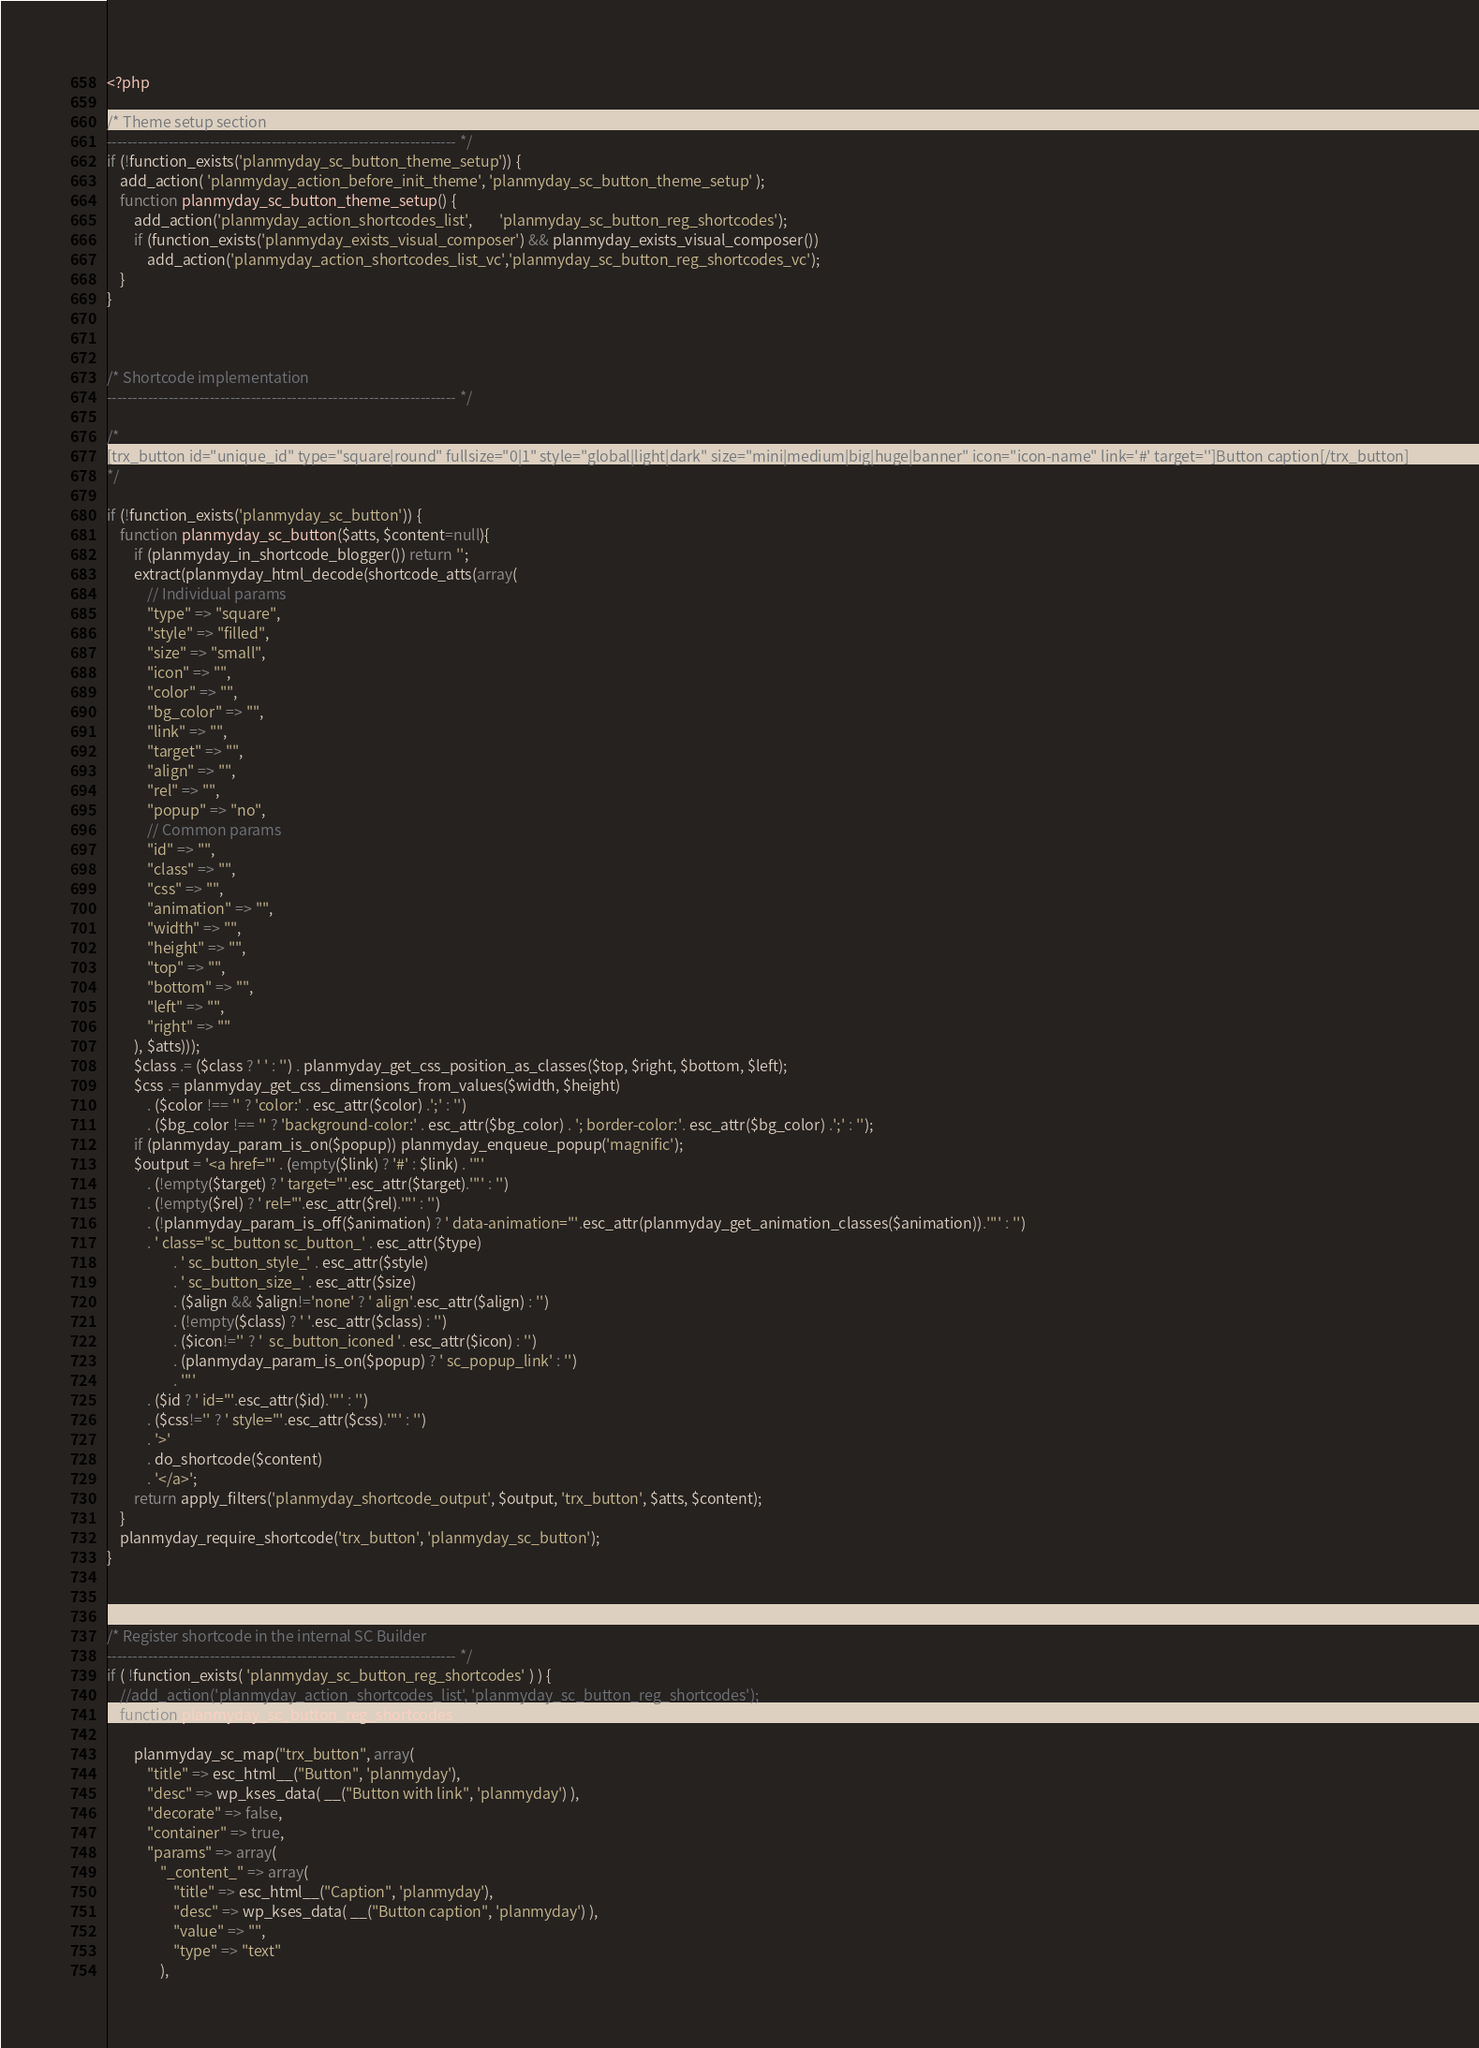<code> <loc_0><loc_0><loc_500><loc_500><_PHP_><?php

/* Theme setup section
-------------------------------------------------------------------- */
if (!function_exists('planmyday_sc_button_theme_setup')) {
	add_action( 'planmyday_action_before_init_theme', 'planmyday_sc_button_theme_setup' );
	function planmyday_sc_button_theme_setup() {
		add_action('planmyday_action_shortcodes_list', 		'planmyday_sc_button_reg_shortcodes');
		if (function_exists('planmyday_exists_visual_composer') && planmyday_exists_visual_composer())
			add_action('planmyday_action_shortcodes_list_vc','planmyday_sc_button_reg_shortcodes_vc');
	}
}



/* Shortcode implementation
-------------------------------------------------------------------- */

/*
[trx_button id="unique_id" type="square|round" fullsize="0|1" style="global|light|dark" size="mini|medium|big|huge|banner" icon="icon-name" link='#' target='']Button caption[/trx_button]
*/

if (!function_exists('planmyday_sc_button')) {	
	function planmyday_sc_button($atts, $content=null){	
		if (planmyday_in_shortcode_blogger()) return '';
		extract(planmyday_html_decode(shortcode_atts(array(
			// Individual params
			"type" => "square",
			"style" => "filled",
			"size" => "small",
			"icon" => "",
			"color" => "",
			"bg_color" => "",
			"link" => "",
			"target" => "",
			"align" => "",
			"rel" => "",
			"popup" => "no",
			// Common params
			"id" => "",
			"class" => "",
			"css" => "",
			"animation" => "",
			"width" => "",
			"height" => "",
			"top" => "",
			"bottom" => "",
			"left" => "",
			"right" => ""
		), $atts)));
		$class .= ($class ? ' ' : '') . planmyday_get_css_position_as_classes($top, $right, $bottom, $left);
		$css .= planmyday_get_css_dimensions_from_values($width, $height)
			. ($color !== '' ? 'color:' . esc_attr($color) .';' : '')
			. ($bg_color !== '' ? 'background-color:' . esc_attr($bg_color) . '; border-color:'. esc_attr($bg_color) .';' : '');
		if (planmyday_param_is_on($popup)) planmyday_enqueue_popup('magnific');
		$output = '<a href="' . (empty($link) ? '#' : $link) . '"'
			. (!empty($target) ? ' target="'.esc_attr($target).'"' : '')
			. (!empty($rel) ? ' rel="'.esc_attr($rel).'"' : '')
			. (!planmyday_param_is_off($animation) ? ' data-animation="'.esc_attr(planmyday_get_animation_classes($animation)).'"' : '')
			. ' class="sc_button sc_button_' . esc_attr($type) 
					. ' sc_button_style_' . esc_attr($style) 
					. ' sc_button_size_' . esc_attr($size)
					. ($align && $align!='none' ? ' align'.esc_attr($align) : '') 
					. (!empty($class) ? ' '.esc_attr($class) : '')
					. ($icon!='' ? '  sc_button_iconed '. esc_attr($icon) : '') 
					. (planmyday_param_is_on($popup) ? ' sc_popup_link' : '') 
					. '"'
			. ($id ? ' id="'.esc_attr($id).'"' : '') 
			. ($css!='' ? ' style="'.esc_attr($css).'"' : '') 
			. '>'
			. do_shortcode($content)
			. '</a>';
		return apply_filters('planmyday_shortcode_output', $output, 'trx_button', $atts, $content);
	}
	planmyday_require_shortcode('trx_button', 'planmyday_sc_button');
}



/* Register shortcode in the internal SC Builder
-------------------------------------------------------------------- */
if ( !function_exists( 'planmyday_sc_button_reg_shortcodes' ) ) {
	//add_action('planmyday_action_shortcodes_list', 'planmyday_sc_button_reg_shortcodes');
	function planmyday_sc_button_reg_shortcodes() {
	
		planmyday_sc_map("trx_button", array(
			"title" => esc_html__("Button", 'planmyday'),
			"desc" => wp_kses_data( __("Button with link", 'planmyday') ),
			"decorate" => false,
			"container" => true,
			"params" => array(
				"_content_" => array(
					"title" => esc_html__("Caption", 'planmyday'),
					"desc" => wp_kses_data( __("Button caption", 'planmyday') ),
					"value" => "",
					"type" => "text"
				),</code> 